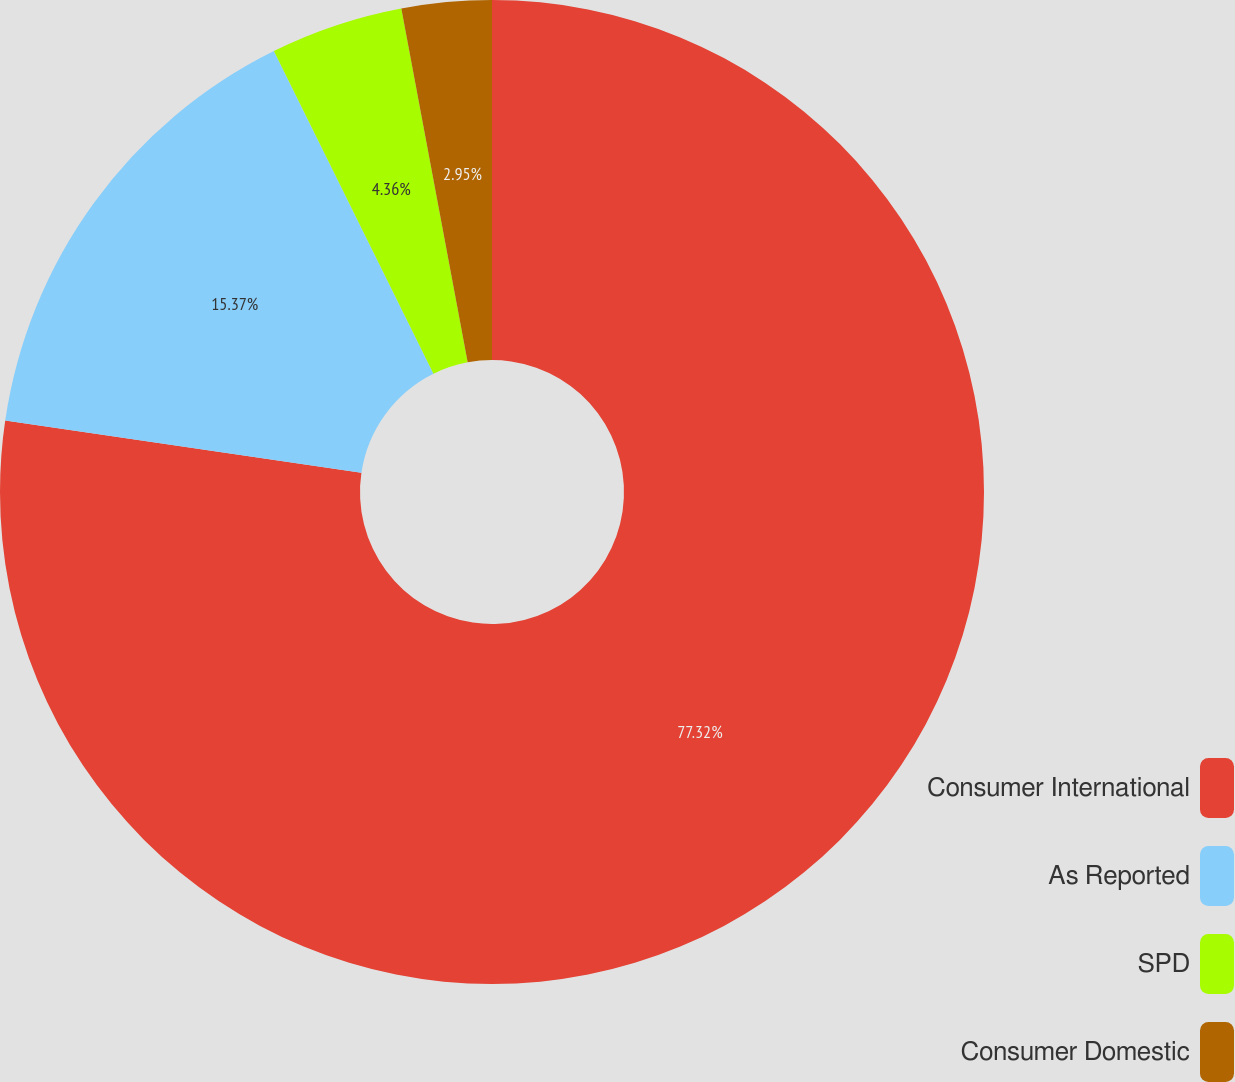<chart> <loc_0><loc_0><loc_500><loc_500><pie_chart><fcel>Consumer International<fcel>As Reported<fcel>SPD<fcel>Consumer Domestic<nl><fcel>77.32%<fcel>15.37%<fcel>4.36%<fcel>2.95%<nl></chart> 